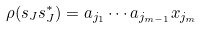Convert formula to latex. <formula><loc_0><loc_0><loc_500><loc_500>\rho ( s _ { J } s _ { J } ^ { * } ) = a _ { j _ { 1 } } \cdots a _ { j _ { m - 1 } } x _ { j _ { m } }</formula> 